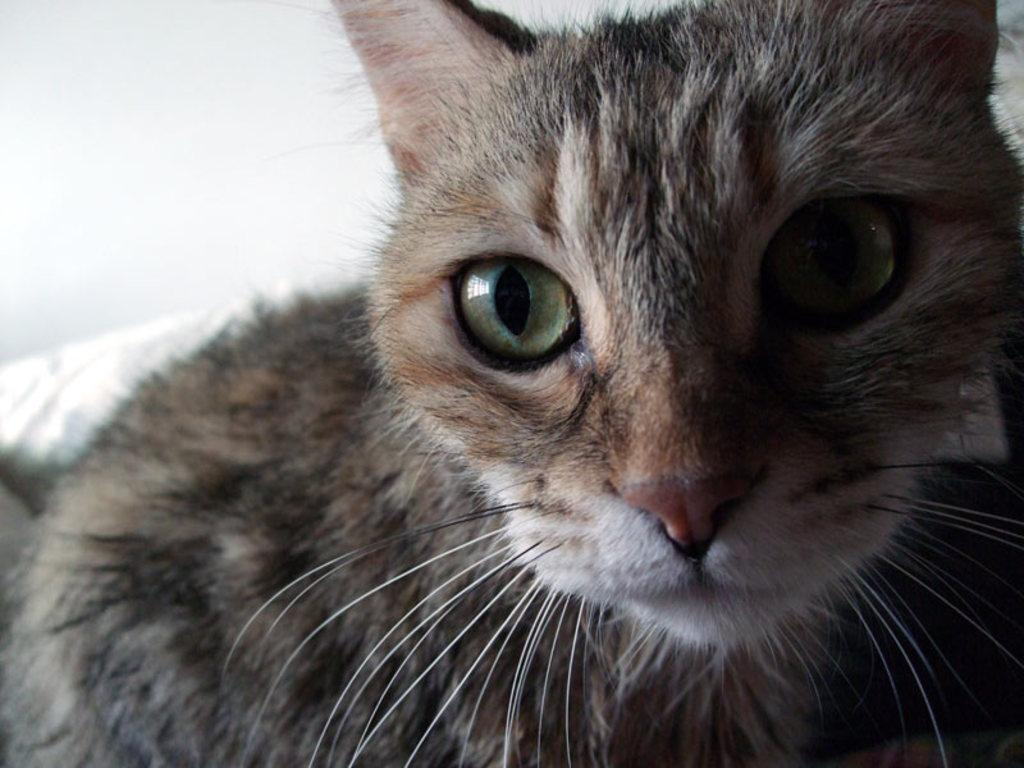What animal is present in the image? There is a cat in the image. Where is the cat located in the image? The cat is in the middle of the image. What can be seen in the background of the image? There is a wall in the background of the image. What type of worm can be seen crawling on the grass in the image? There is no grass or worm present in the image; it features a cat in the middle of the image with a wall in the background. 